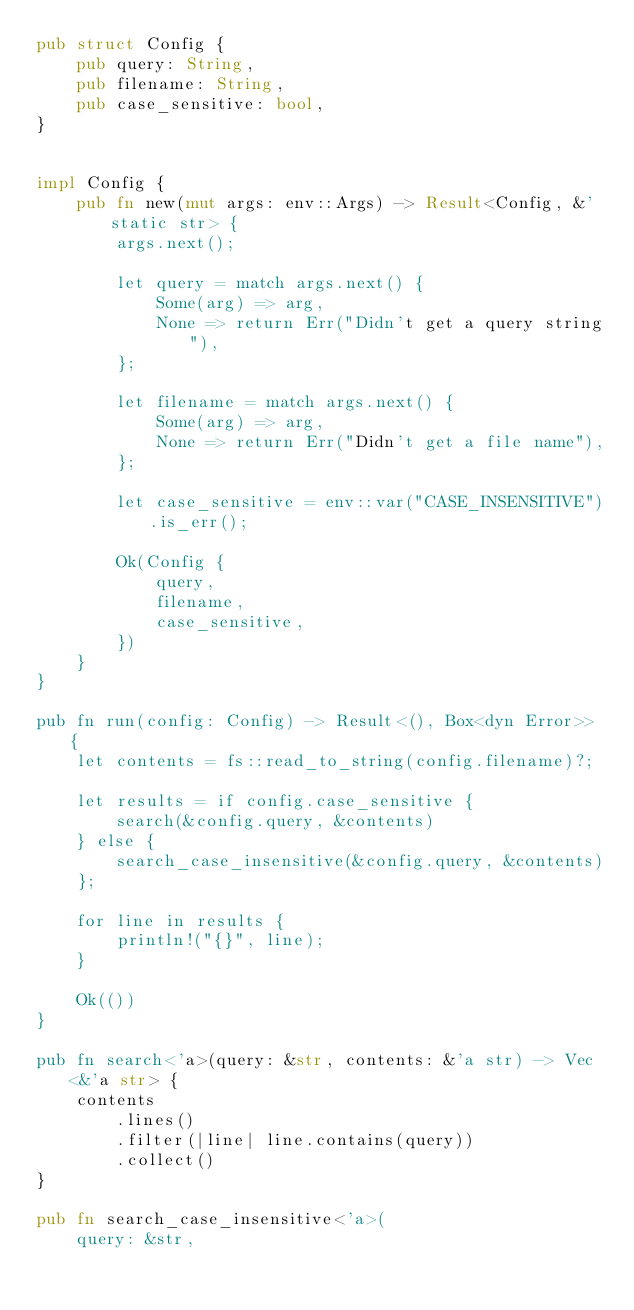<code> <loc_0><loc_0><loc_500><loc_500><_Rust_>pub struct Config {
    pub query: String,
    pub filename: String,
    pub case_sensitive: bool,
}


impl Config {
    pub fn new(mut args: env::Args) -> Result<Config, &'static str> {
        args.next();

        let query = match args.next() {
            Some(arg) => arg,
            None => return Err("Didn't get a query string"),
        };

        let filename = match args.next() {
            Some(arg) => arg,
            None => return Err("Didn't get a file name"),
        };

        let case_sensitive = env::var("CASE_INSENSITIVE").is_err();

        Ok(Config {
            query,
            filename,
            case_sensitive,
        })
    }
}

pub fn run(config: Config) -> Result<(), Box<dyn Error>> {
    let contents = fs::read_to_string(config.filename)?;

    let results = if config.case_sensitive {
        search(&config.query, &contents)
    } else {
        search_case_insensitive(&config.query, &contents)
    };

    for line in results {
        println!("{}", line);
    }

    Ok(())
}

pub fn search<'a>(query: &str, contents: &'a str) -> Vec<&'a str> {
    contents
        .lines()
        .filter(|line| line.contains(query))
        .collect()
}

pub fn search_case_insensitive<'a>(
    query: &str,</code> 